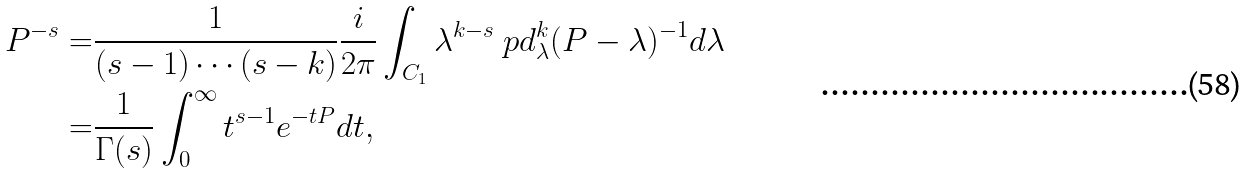Convert formula to latex. <formula><loc_0><loc_0><loc_500><loc_500>P ^ { - s } = & \frac { 1 } { ( s - 1 ) \cdots ( s - k ) } \frac { i } { 2 \pi } \int _ { C _ { 1 } } \lambda ^ { k - s } \ p d ^ { k } _ { \lambda } ( P - \lambda ) ^ { - 1 } d \lambda \\ = & \frac { 1 } { \Gamma ( s ) } \int _ { 0 } ^ { \infty } t ^ { s - 1 } e ^ { - t P } d t ,</formula> 